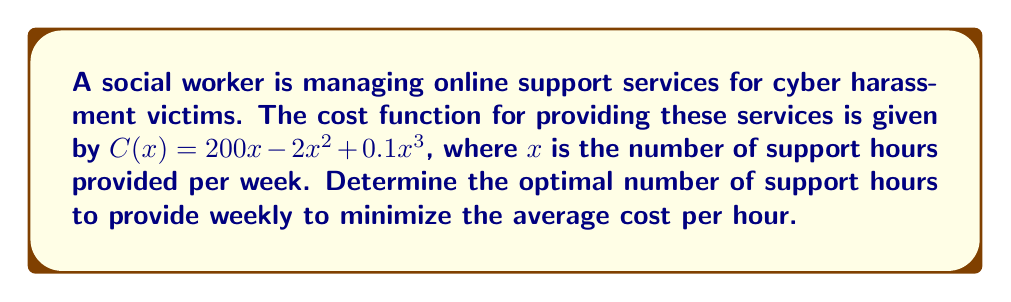Can you answer this question? 1) The average cost function is given by:
   $$A(x) = \frac{C(x)}{x} = \frac{200x - 2x^2 + 0.1x^3}{x} = 200 - 2x + 0.1x^2$$

2) To minimize the average cost, we need to find where its derivative equals zero:
   $$\frac{d}{dx}A(x) = -2 + 0.2x$$

3) Set this equal to zero and solve:
   $$-2 + 0.2x = 0$$
   $$0.2x = 2$$
   $$x = 10$$

4) To confirm this is a minimum, we check the second derivative:
   $$\frac{d^2}{dx^2}A(x) = 0.2 > 0$$

   Since this is positive, $x = 10$ gives a local minimum.

5) Therefore, the optimal number of support hours to provide weekly is 10 hours.
Answer: 10 hours 